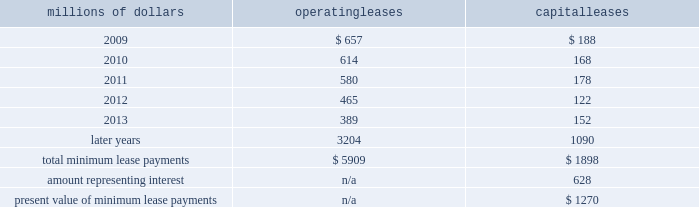14 .
Leases we lease certain locomotives , freight cars , and other property .
The consolidated statement of financial position as of december 31 , 2008 and 2007 included $ 2024 million , net of $ 869 million of amortization , and $ 2062 million , net of $ 887 million of amortization , respectively , for properties held under capital leases .
A charge to income resulting from the amortization for assets held under capital leases is included within depreciation expense in our consolidated statements of income .
Future minimum lease payments for operating and capital leases with initial or remaining non-cancelable lease terms in excess of one year as of december 31 , 2008 were as follows : millions of dollars operating leases capital leases .
The majority of capital lease payments relate to locomotives .
Rent expense for operating leases with terms exceeding one month was $ 747 million in 2008 , $ 810 million in 2007 , and $ 798 million in 2006 .
When cash rental payments are not made on a straight-line basis , we recognize variable rental expense on a straight-line basis over the lease term .
Contingent rentals and sub-rentals are not significant .
15 .
Commitments and contingencies asserted and unasserted claims 2013 various claims and lawsuits are pending against us and certain of our subsidiaries .
We cannot fully determine the effect of all asserted and unasserted claims on our consolidated results of operations , financial condition , or liquidity ; however , to the extent possible , where asserted and unasserted claims are considered probable and where such claims can be reasonably estimated , we have recorded a liability .
We do not expect that any known lawsuits , claims , environmental costs , commitments , contingent liabilities , or guarantees will have a material adverse effect on our consolidated results of operations , financial condition , or liquidity after taking into account liabilities and insurance recoveries previously recorded for these matters .
Personal injury 2013 the cost of personal injuries to employees and others related to our activities is charged to expense based on estimates of the ultimate cost and number of incidents each year .
We use third-party actuaries to assist us in measuring the expense and liability , including unasserted claims .
The federal employers 2019 liability act ( fela ) governs compensation for work-related accidents .
Under fela , damages are assessed based on a finding of fault through litigation or out-of-court settlements .
We offer a comprehensive variety of services and rehabilitation programs for employees who are injured at our personal injury liability is discounted to present value using applicable u.s .
Treasury rates .
Approximately 88% ( 88 % ) of the recorded liability related to asserted claims , and approximately 12% ( 12 % ) related to unasserted claims at december 31 , 2008 .
Because of the uncertainty surrounding the ultimate outcome of personal injury claims , it is reasonably possible that future costs to settle these claims may range from .
What percentage of total minimum lease payments are operating leases? 
Computations: (5909 / (5909 + 1898))
Answer: 0.75688. 